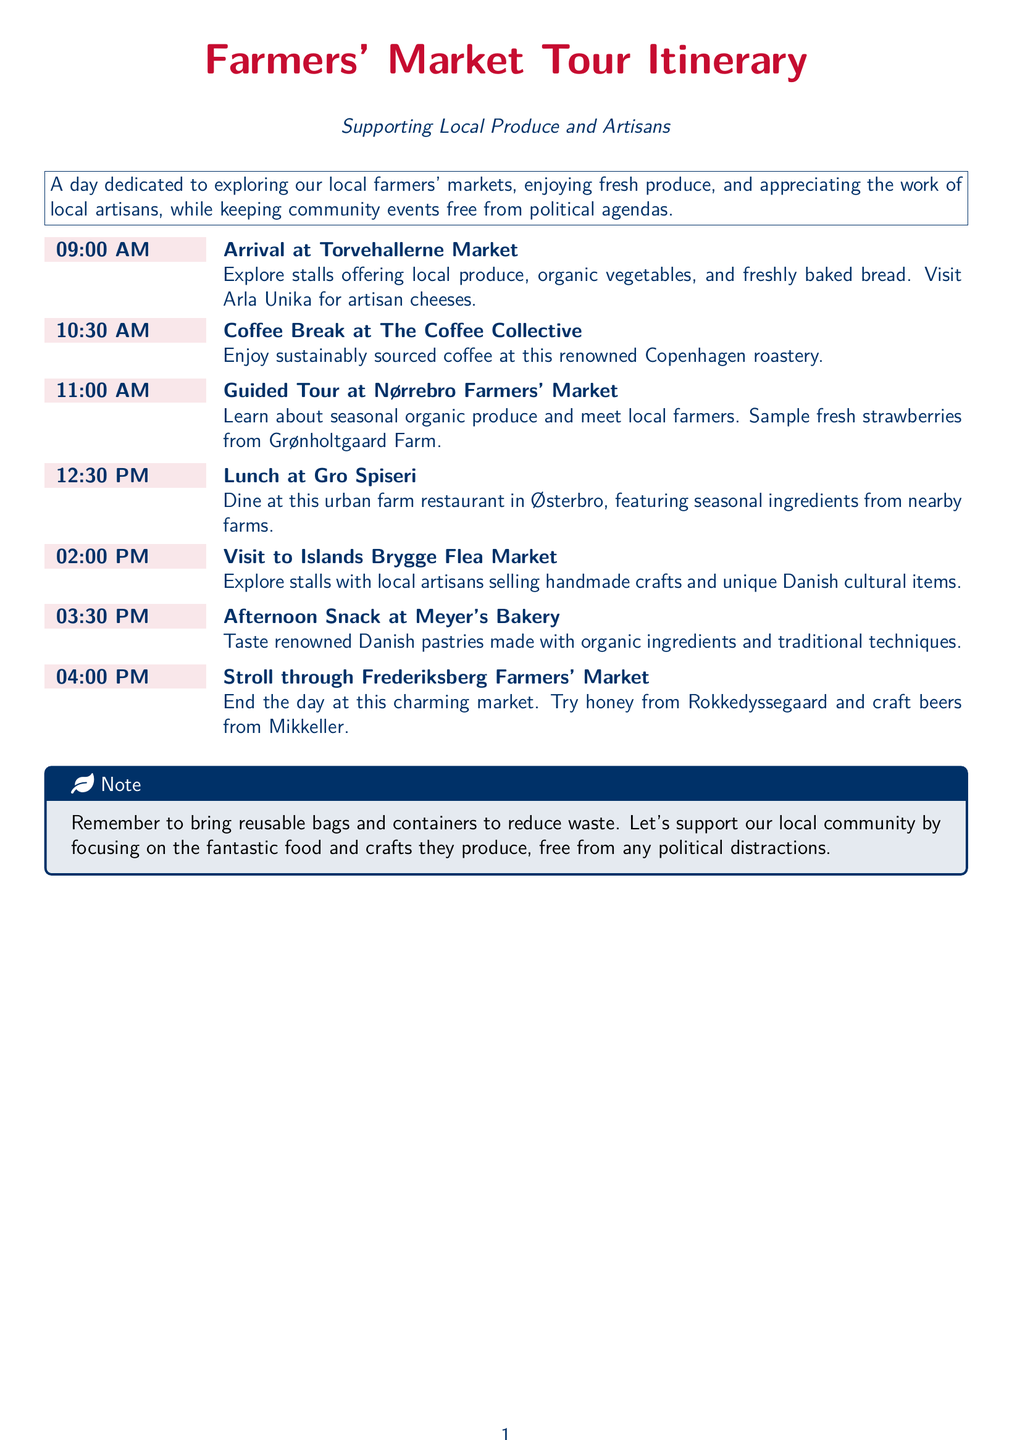What time does the tour start? The tour starts at 09:00 AM as indicated in the itinerary.
Answer: 09:00 AM Where will the coffee break take place? The coffee break is scheduled at The Coffee Collective according to the itinerary.
Answer: The Coffee Collective What is featured for lunch at Gro Spiseri? The itinerary mentions that Gro Spiseri features seasonal ingredients from nearby farms.
Answer: Seasonal ingredients Who provides the artisan cheeses? The document specifies that Arla Unika offers artisan cheeses at the Torvehallerne Market.
Answer: Arla Unika What types of products can be found at the Islands Brygge Flea Market? The document states that local artisans sell handmade crafts and unique Danish cultural items at the flea market.
Answer: Handmade crafts and unique Danish cultural items What should participants bring to reduce waste? The note at the end of the itinerary suggests bringing reusable bags and containers to reduce waste.
Answer: Reusable bags and containers At which farmers' market can visitors try honey from Rokkedyssegaard? The itinerary indicates that honey from Rokkedyssegaard can be tried at Frederiksberg Farmers' Market.
Answer: Frederiksberg Farmers' Market What is a key theme of the event as stated in the introduction? The introduction emphasizes keeping community events free from political agendas as a key theme of the event.
Answer: Free from political agendas 